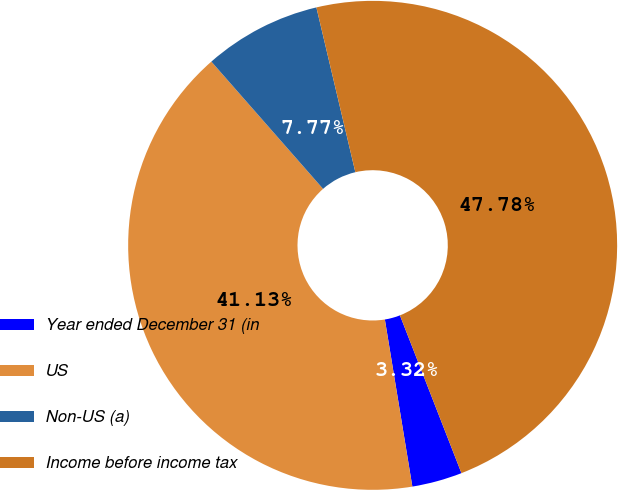Convert chart to OTSL. <chart><loc_0><loc_0><loc_500><loc_500><pie_chart><fcel>Year ended December 31 (in<fcel>US<fcel>Non-US (a)<fcel>Income before income tax<nl><fcel>3.32%<fcel>41.13%<fcel>7.77%<fcel>47.78%<nl></chart> 